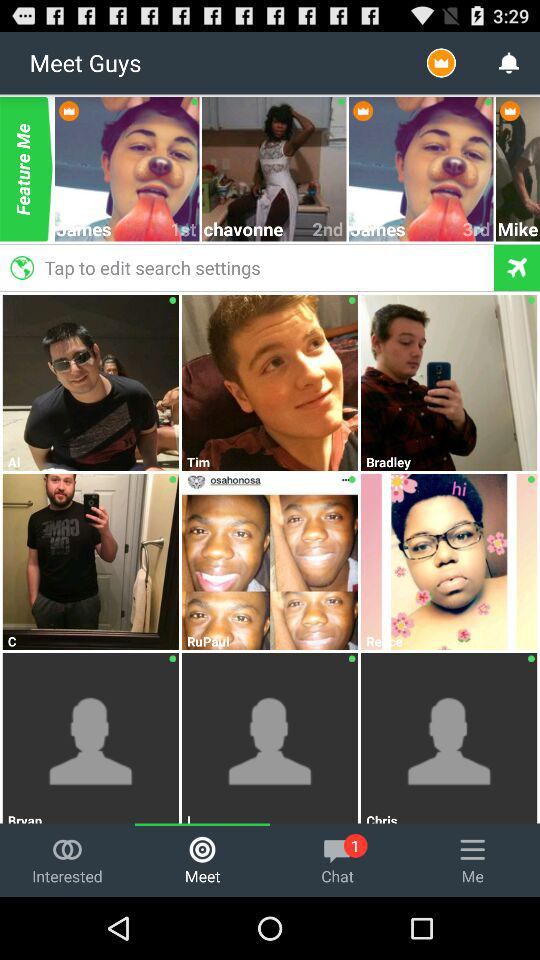How many unread chats are there? There is 1 unread chat. 